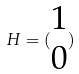<formula> <loc_0><loc_0><loc_500><loc_500>H = ( \begin{matrix} 1 \\ 0 \end{matrix} )</formula> 